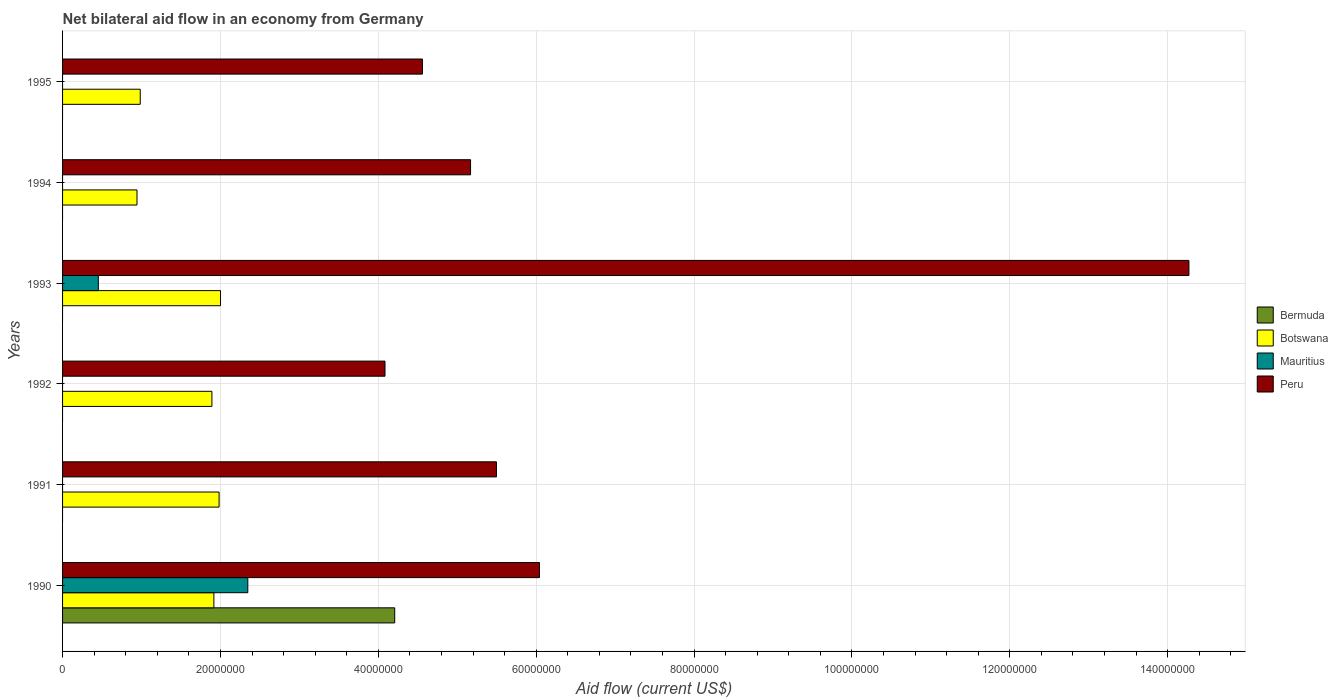How many different coloured bars are there?
Give a very brief answer. 4. How many groups of bars are there?
Your answer should be very brief. 6. Are the number of bars per tick equal to the number of legend labels?
Provide a succinct answer. No. How many bars are there on the 2nd tick from the top?
Your answer should be compact. 2. How many bars are there on the 4th tick from the bottom?
Offer a terse response. 3. What is the label of the 3rd group of bars from the top?
Ensure brevity in your answer.  1993. Across all years, what is the maximum net bilateral aid flow in Peru?
Your answer should be compact. 1.43e+08. Across all years, what is the minimum net bilateral aid flow in Botswana?
Provide a succinct answer. 9.43e+06. What is the total net bilateral aid flow in Mauritius in the graph?
Keep it short and to the point. 2.80e+07. What is the difference between the net bilateral aid flow in Botswana in 1990 and that in 1993?
Ensure brevity in your answer.  -8.40e+05. What is the difference between the net bilateral aid flow in Mauritius in 1992 and the net bilateral aid flow in Peru in 1994?
Offer a very short reply. -5.17e+07. What is the average net bilateral aid flow in Mauritius per year?
Provide a succinct answer. 4.67e+06. In the year 1991, what is the difference between the net bilateral aid flow in Peru and net bilateral aid flow in Botswana?
Keep it short and to the point. 3.51e+07. In how many years, is the net bilateral aid flow in Peru greater than 116000000 US$?
Give a very brief answer. 1. What is the ratio of the net bilateral aid flow in Peru in 1993 to that in 1995?
Provide a short and direct response. 3.13. Is the difference between the net bilateral aid flow in Peru in 1992 and 1993 greater than the difference between the net bilateral aid flow in Botswana in 1992 and 1993?
Provide a succinct answer. No. What is the difference between the highest and the second highest net bilateral aid flow in Peru?
Your response must be concise. 8.23e+07. What is the difference between the highest and the lowest net bilateral aid flow in Bermuda?
Provide a short and direct response. 4.21e+07. Does the graph contain any zero values?
Ensure brevity in your answer.  Yes. Does the graph contain grids?
Make the answer very short. Yes. What is the title of the graph?
Give a very brief answer. Net bilateral aid flow in an economy from Germany. What is the Aid flow (current US$) of Bermuda in 1990?
Provide a short and direct response. 4.21e+07. What is the Aid flow (current US$) of Botswana in 1990?
Offer a terse response. 1.92e+07. What is the Aid flow (current US$) in Mauritius in 1990?
Keep it short and to the point. 2.35e+07. What is the Aid flow (current US$) of Peru in 1990?
Your answer should be very brief. 6.04e+07. What is the Aid flow (current US$) in Botswana in 1991?
Give a very brief answer. 1.98e+07. What is the Aid flow (current US$) in Peru in 1991?
Offer a very short reply. 5.50e+07. What is the Aid flow (current US$) of Botswana in 1992?
Offer a terse response. 1.89e+07. What is the Aid flow (current US$) of Peru in 1992?
Your answer should be very brief. 4.08e+07. What is the Aid flow (current US$) in Bermuda in 1993?
Give a very brief answer. 0. What is the Aid flow (current US$) in Botswana in 1993?
Your answer should be very brief. 2.00e+07. What is the Aid flow (current US$) in Mauritius in 1993?
Make the answer very short. 4.53e+06. What is the Aid flow (current US$) of Peru in 1993?
Provide a short and direct response. 1.43e+08. What is the Aid flow (current US$) of Bermuda in 1994?
Give a very brief answer. 0. What is the Aid flow (current US$) in Botswana in 1994?
Make the answer very short. 9.43e+06. What is the Aid flow (current US$) of Mauritius in 1994?
Provide a succinct answer. 0. What is the Aid flow (current US$) of Peru in 1994?
Make the answer very short. 5.17e+07. What is the Aid flow (current US$) in Bermuda in 1995?
Your answer should be very brief. 0. What is the Aid flow (current US$) in Botswana in 1995?
Offer a very short reply. 9.84e+06. What is the Aid flow (current US$) of Mauritius in 1995?
Make the answer very short. 0. What is the Aid flow (current US$) in Peru in 1995?
Make the answer very short. 4.56e+07. Across all years, what is the maximum Aid flow (current US$) in Bermuda?
Keep it short and to the point. 4.21e+07. Across all years, what is the maximum Aid flow (current US$) in Botswana?
Give a very brief answer. 2.00e+07. Across all years, what is the maximum Aid flow (current US$) of Mauritius?
Keep it short and to the point. 2.35e+07. Across all years, what is the maximum Aid flow (current US$) in Peru?
Your answer should be compact. 1.43e+08. Across all years, what is the minimum Aid flow (current US$) in Bermuda?
Your answer should be compact. 0. Across all years, what is the minimum Aid flow (current US$) in Botswana?
Ensure brevity in your answer.  9.43e+06. Across all years, what is the minimum Aid flow (current US$) of Peru?
Your answer should be compact. 4.08e+07. What is the total Aid flow (current US$) of Bermuda in the graph?
Your answer should be compact. 4.21e+07. What is the total Aid flow (current US$) in Botswana in the graph?
Make the answer very short. 9.72e+07. What is the total Aid flow (current US$) of Mauritius in the graph?
Give a very brief answer. 2.80e+07. What is the total Aid flow (current US$) of Peru in the graph?
Keep it short and to the point. 3.96e+08. What is the difference between the Aid flow (current US$) of Botswana in 1990 and that in 1991?
Offer a terse response. -6.60e+05. What is the difference between the Aid flow (current US$) of Peru in 1990 and that in 1991?
Provide a short and direct response. 5.45e+06. What is the difference between the Aid flow (current US$) of Peru in 1990 and that in 1992?
Your response must be concise. 1.96e+07. What is the difference between the Aid flow (current US$) of Botswana in 1990 and that in 1993?
Your answer should be compact. -8.40e+05. What is the difference between the Aid flow (current US$) in Mauritius in 1990 and that in 1993?
Make the answer very short. 1.89e+07. What is the difference between the Aid flow (current US$) of Peru in 1990 and that in 1993?
Ensure brevity in your answer.  -8.23e+07. What is the difference between the Aid flow (current US$) of Botswana in 1990 and that in 1994?
Provide a short and direct response. 9.74e+06. What is the difference between the Aid flow (current US$) in Peru in 1990 and that in 1994?
Your response must be concise. 8.73e+06. What is the difference between the Aid flow (current US$) in Botswana in 1990 and that in 1995?
Your answer should be compact. 9.33e+06. What is the difference between the Aid flow (current US$) in Peru in 1990 and that in 1995?
Give a very brief answer. 1.48e+07. What is the difference between the Aid flow (current US$) in Botswana in 1991 and that in 1992?
Keep it short and to the point. 9.10e+05. What is the difference between the Aid flow (current US$) in Peru in 1991 and that in 1992?
Give a very brief answer. 1.41e+07. What is the difference between the Aid flow (current US$) in Peru in 1991 and that in 1993?
Make the answer very short. -8.77e+07. What is the difference between the Aid flow (current US$) of Botswana in 1991 and that in 1994?
Offer a very short reply. 1.04e+07. What is the difference between the Aid flow (current US$) in Peru in 1991 and that in 1994?
Keep it short and to the point. 3.28e+06. What is the difference between the Aid flow (current US$) in Botswana in 1991 and that in 1995?
Your answer should be very brief. 9.99e+06. What is the difference between the Aid flow (current US$) in Peru in 1991 and that in 1995?
Provide a short and direct response. 9.38e+06. What is the difference between the Aid flow (current US$) in Botswana in 1992 and that in 1993?
Provide a succinct answer. -1.09e+06. What is the difference between the Aid flow (current US$) of Peru in 1992 and that in 1993?
Give a very brief answer. -1.02e+08. What is the difference between the Aid flow (current US$) in Botswana in 1992 and that in 1994?
Provide a short and direct response. 9.49e+06. What is the difference between the Aid flow (current US$) of Peru in 1992 and that in 1994?
Ensure brevity in your answer.  -1.08e+07. What is the difference between the Aid flow (current US$) in Botswana in 1992 and that in 1995?
Give a very brief answer. 9.08e+06. What is the difference between the Aid flow (current US$) in Peru in 1992 and that in 1995?
Your answer should be very brief. -4.74e+06. What is the difference between the Aid flow (current US$) in Botswana in 1993 and that in 1994?
Keep it short and to the point. 1.06e+07. What is the difference between the Aid flow (current US$) in Peru in 1993 and that in 1994?
Your answer should be compact. 9.10e+07. What is the difference between the Aid flow (current US$) of Botswana in 1993 and that in 1995?
Give a very brief answer. 1.02e+07. What is the difference between the Aid flow (current US$) of Peru in 1993 and that in 1995?
Keep it short and to the point. 9.71e+07. What is the difference between the Aid flow (current US$) of Botswana in 1994 and that in 1995?
Keep it short and to the point. -4.10e+05. What is the difference between the Aid flow (current US$) of Peru in 1994 and that in 1995?
Your answer should be very brief. 6.10e+06. What is the difference between the Aid flow (current US$) of Bermuda in 1990 and the Aid flow (current US$) of Botswana in 1991?
Your answer should be compact. 2.22e+07. What is the difference between the Aid flow (current US$) in Bermuda in 1990 and the Aid flow (current US$) in Peru in 1991?
Keep it short and to the point. -1.29e+07. What is the difference between the Aid flow (current US$) in Botswana in 1990 and the Aid flow (current US$) in Peru in 1991?
Offer a terse response. -3.58e+07. What is the difference between the Aid flow (current US$) in Mauritius in 1990 and the Aid flow (current US$) in Peru in 1991?
Provide a succinct answer. -3.15e+07. What is the difference between the Aid flow (current US$) of Bermuda in 1990 and the Aid flow (current US$) of Botswana in 1992?
Your answer should be very brief. 2.32e+07. What is the difference between the Aid flow (current US$) in Bermuda in 1990 and the Aid flow (current US$) in Peru in 1992?
Offer a terse response. 1.23e+06. What is the difference between the Aid flow (current US$) of Botswana in 1990 and the Aid flow (current US$) of Peru in 1992?
Keep it short and to the point. -2.17e+07. What is the difference between the Aid flow (current US$) in Mauritius in 1990 and the Aid flow (current US$) in Peru in 1992?
Offer a terse response. -1.74e+07. What is the difference between the Aid flow (current US$) in Bermuda in 1990 and the Aid flow (current US$) in Botswana in 1993?
Provide a short and direct response. 2.21e+07. What is the difference between the Aid flow (current US$) in Bermuda in 1990 and the Aid flow (current US$) in Mauritius in 1993?
Provide a short and direct response. 3.76e+07. What is the difference between the Aid flow (current US$) of Bermuda in 1990 and the Aid flow (current US$) of Peru in 1993?
Offer a very short reply. -1.01e+08. What is the difference between the Aid flow (current US$) in Botswana in 1990 and the Aid flow (current US$) in Mauritius in 1993?
Your answer should be compact. 1.46e+07. What is the difference between the Aid flow (current US$) in Botswana in 1990 and the Aid flow (current US$) in Peru in 1993?
Ensure brevity in your answer.  -1.24e+08. What is the difference between the Aid flow (current US$) of Mauritius in 1990 and the Aid flow (current US$) of Peru in 1993?
Your answer should be very brief. -1.19e+08. What is the difference between the Aid flow (current US$) in Bermuda in 1990 and the Aid flow (current US$) in Botswana in 1994?
Offer a terse response. 3.26e+07. What is the difference between the Aid flow (current US$) of Bermuda in 1990 and the Aid flow (current US$) of Peru in 1994?
Offer a very short reply. -9.61e+06. What is the difference between the Aid flow (current US$) of Botswana in 1990 and the Aid flow (current US$) of Peru in 1994?
Your answer should be very brief. -3.25e+07. What is the difference between the Aid flow (current US$) of Mauritius in 1990 and the Aid flow (current US$) of Peru in 1994?
Provide a succinct answer. -2.82e+07. What is the difference between the Aid flow (current US$) of Bermuda in 1990 and the Aid flow (current US$) of Botswana in 1995?
Provide a short and direct response. 3.22e+07. What is the difference between the Aid flow (current US$) in Bermuda in 1990 and the Aid flow (current US$) in Peru in 1995?
Keep it short and to the point. -3.51e+06. What is the difference between the Aid flow (current US$) of Botswana in 1990 and the Aid flow (current US$) of Peru in 1995?
Keep it short and to the point. -2.64e+07. What is the difference between the Aid flow (current US$) in Mauritius in 1990 and the Aid flow (current US$) in Peru in 1995?
Provide a short and direct response. -2.21e+07. What is the difference between the Aid flow (current US$) of Botswana in 1991 and the Aid flow (current US$) of Peru in 1992?
Your answer should be compact. -2.10e+07. What is the difference between the Aid flow (current US$) of Botswana in 1991 and the Aid flow (current US$) of Mauritius in 1993?
Make the answer very short. 1.53e+07. What is the difference between the Aid flow (current US$) of Botswana in 1991 and the Aid flow (current US$) of Peru in 1993?
Ensure brevity in your answer.  -1.23e+08. What is the difference between the Aid flow (current US$) in Botswana in 1991 and the Aid flow (current US$) in Peru in 1994?
Give a very brief answer. -3.19e+07. What is the difference between the Aid flow (current US$) in Botswana in 1991 and the Aid flow (current US$) in Peru in 1995?
Your answer should be compact. -2.58e+07. What is the difference between the Aid flow (current US$) in Botswana in 1992 and the Aid flow (current US$) in Mauritius in 1993?
Give a very brief answer. 1.44e+07. What is the difference between the Aid flow (current US$) in Botswana in 1992 and the Aid flow (current US$) in Peru in 1993?
Provide a succinct answer. -1.24e+08. What is the difference between the Aid flow (current US$) of Botswana in 1992 and the Aid flow (current US$) of Peru in 1994?
Your answer should be compact. -3.28e+07. What is the difference between the Aid flow (current US$) of Botswana in 1992 and the Aid flow (current US$) of Peru in 1995?
Your answer should be compact. -2.67e+07. What is the difference between the Aid flow (current US$) in Botswana in 1993 and the Aid flow (current US$) in Peru in 1994?
Ensure brevity in your answer.  -3.17e+07. What is the difference between the Aid flow (current US$) of Mauritius in 1993 and the Aid flow (current US$) of Peru in 1994?
Provide a short and direct response. -4.72e+07. What is the difference between the Aid flow (current US$) of Botswana in 1993 and the Aid flow (current US$) of Peru in 1995?
Offer a very short reply. -2.56e+07. What is the difference between the Aid flow (current US$) of Mauritius in 1993 and the Aid flow (current US$) of Peru in 1995?
Your answer should be very brief. -4.11e+07. What is the difference between the Aid flow (current US$) in Botswana in 1994 and the Aid flow (current US$) in Peru in 1995?
Provide a succinct answer. -3.62e+07. What is the average Aid flow (current US$) in Bermuda per year?
Your answer should be very brief. 7.01e+06. What is the average Aid flow (current US$) of Botswana per year?
Give a very brief answer. 1.62e+07. What is the average Aid flow (current US$) in Mauritius per year?
Offer a very short reply. 4.67e+06. What is the average Aid flow (current US$) of Peru per year?
Offer a very short reply. 6.60e+07. In the year 1990, what is the difference between the Aid flow (current US$) in Bermuda and Aid flow (current US$) in Botswana?
Ensure brevity in your answer.  2.29e+07. In the year 1990, what is the difference between the Aid flow (current US$) in Bermuda and Aid flow (current US$) in Mauritius?
Ensure brevity in your answer.  1.86e+07. In the year 1990, what is the difference between the Aid flow (current US$) of Bermuda and Aid flow (current US$) of Peru?
Provide a succinct answer. -1.83e+07. In the year 1990, what is the difference between the Aid flow (current US$) in Botswana and Aid flow (current US$) in Mauritius?
Provide a short and direct response. -4.30e+06. In the year 1990, what is the difference between the Aid flow (current US$) of Botswana and Aid flow (current US$) of Peru?
Give a very brief answer. -4.12e+07. In the year 1990, what is the difference between the Aid flow (current US$) in Mauritius and Aid flow (current US$) in Peru?
Make the answer very short. -3.70e+07. In the year 1991, what is the difference between the Aid flow (current US$) of Botswana and Aid flow (current US$) of Peru?
Your answer should be very brief. -3.51e+07. In the year 1992, what is the difference between the Aid flow (current US$) of Botswana and Aid flow (current US$) of Peru?
Give a very brief answer. -2.19e+07. In the year 1993, what is the difference between the Aid flow (current US$) in Botswana and Aid flow (current US$) in Mauritius?
Make the answer very short. 1.55e+07. In the year 1993, what is the difference between the Aid flow (current US$) of Botswana and Aid flow (current US$) of Peru?
Give a very brief answer. -1.23e+08. In the year 1993, what is the difference between the Aid flow (current US$) in Mauritius and Aid flow (current US$) in Peru?
Your answer should be very brief. -1.38e+08. In the year 1994, what is the difference between the Aid flow (current US$) in Botswana and Aid flow (current US$) in Peru?
Provide a short and direct response. -4.23e+07. In the year 1995, what is the difference between the Aid flow (current US$) in Botswana and Aid flow (current US$) in Peru?
Give a very brief answer. -3.58e+07. What is the ratio of the Aid flow (current US$) of Botswana in 1990 to that in 1991?
Give a very brief answer. 0.97. What is the ratio of the Aid flow (current US$) of Peru in 1990 to that in 1991?
Provide a succinct answer. 1.1. What is the ratio of the Aid flow (current US$) in Botswana in 1990 to that in 1992?
Offer a terse response. 1.01. What is the ratio of the Aid flow (current US$) of Peru in 1990 to that in 1992?
Offer a very short reply. 1.48. What is the ratio of the Aid flow (current US$) in Botswana in 1990 to that in 1993?
Provide a short and direct response. 0.96. What is the ratio of the Aid flow (current US$) in Mauritius in 1990 to that in 1993?
Offer a very short reply. 5.18. What is the ratio of the Aid flow (current US$) of Peru in 1990 to that in 1993?
Provide a short and direct response. 0.42. What is the ratio of the Aid flow (current US$) of Botswana in 1990 to that in 1994?
Your answer should be compact. 2.03. What is the ratio of the Aid flow (current US$) in Peru in 1990 to that in 1994?
Your answer should be very brief. 1.17. What is the ratio of the Aid flow (current US$) of Botswana in 1990 to that in 1995?
Provide a succinct answer. 1.95. What is the ratio of the Aid flow (current US$) in Peru in 1990 to that in 1995?
Your response must be concise. 1.33. What is the ratio of the Aid flow (current US$) of Botswana in 1991 to that in 1992?
Provide a succinct answer. 1.05. What is the ratio of the Aid flow (current US$) in Peru in 1991 to that in 1992?
Keep it short and to the point. 1.35. What is the ratio of the Aid flow (current US$) in Botswana in 1991 to that in 1993?
Make the answer very short. 0.99. What is the ratio of the Aid flow (current US$) in Peru in 1991 to that in 1993?
Your answer should be very brief. 0.39. What is the ratio of the Aid flow (current US$) in Botswana in 1991 to that in 1994?
Provide a short and direct response. 2.1. What is the ratio of the Aid flow (current US$) of Peru in 1991 to that in 1994?
Give a very brief answer. 1.06. What is the ratio of the Aid flow (current US$) of Botswana in 1991 to that in 1995?
Ensure brevity in your answer.  2.02. What is the ratio of the Aid flow (current US$) in Peru in 1991 to that in 1995?
Your response must be concise. 1.21. What is the ratio of the Aid flow (current US$) in Botswana in 1992 to that in 1993?
Offer a terse response. 0.95. What is the ratio of the Aid flow (current US$) in Peru in 1992 to that in 1993?
Offer a very short reply. 0.29. What is the ratio of the Aid flow (current US$) in Botswana in 1992 to that in 1994?
Your answer should be very brief. 2.01. What is the ratio of the Aid flow (current US$) of Peru in 1992 to that in 1994?
Your response must be concise. 0.79. What is the ratio of the Aid flow (current US$) in Botswana in 1992 to that in 1995?
Give a very brief answer. 1.92. What is the ratio of the Aid flow (current US$) in Peru in 1992 to that in 1995?
Your answer should be compact. 0.9. What is the ratio of the Aid flow (current US$) in Botswana in 1993 to that in 1994?
Provide a short and direct response. 2.12. What is the ratio of the Aid flow (current US$) of Peru in 1993 to that in 1994?
Provide a short and direct response. 2.76. What is the ratio of the Aid flow (current US$) in Botswana in 1993 to that in 1995?
Provide a succinct answer. 2.03. What is the ratio of the Aid flow (current US$) in Peru in 1993 to that in 1995?
Provide a short and direct response. 3.13. What is the ratio of the Aid flow (current US$) in Peru in 1994 to that in 1995?
Your response must be concise. 1.13. What is the difference between the highest and the second highest Aid flow (current US$) in Peru?
Ensure brevity in your answer.  8.23e+07. What is the difference between the highest and the lowest Aid flow (current US$) in Bermuda?
Your answer should be compact. 4.21e+07. What is the difference between the highest and the lowest Aid flow (current US$) in Botswana?
Ensure brevity in your answer.  1.06e+07. What is the difference between the highest and the lowest Aid flow (current US$) of Mauritius?
Ensure brevity in your answer.  2.35e+07. What is the difference between the highest and the lowest Aid flow (current US$) in Peru?
Offer a terse response. 1.02e+08. 